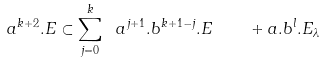Convert formula to latex. <formula><loc_0><loc_0><loc_500><loc_500>a ^ { k + 2 } . E \subset \sum _ { j = 0 } ^ { k } \ a ^ { j + 1 } . b ^ { k + 1 - j } . E \quad + a . b ^ { l } . E _ { \lambda }</formula> 